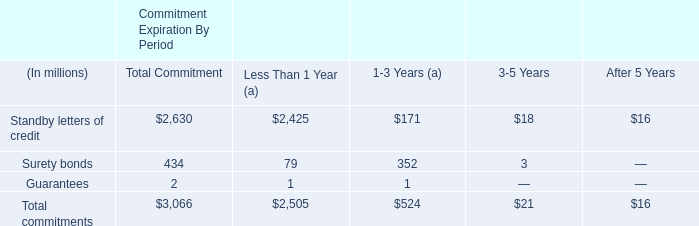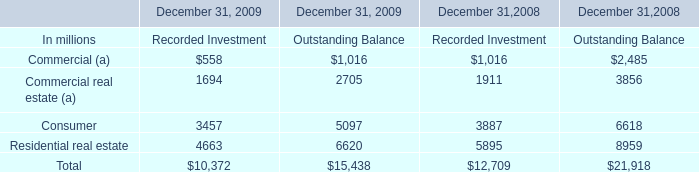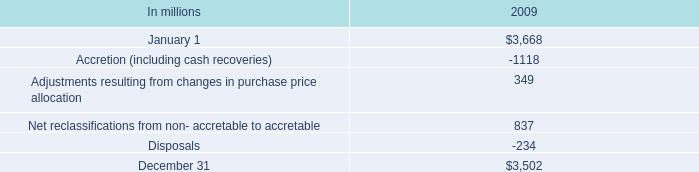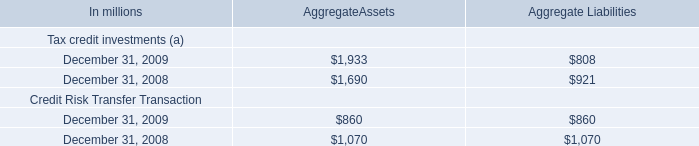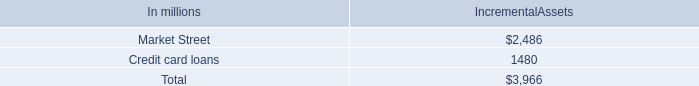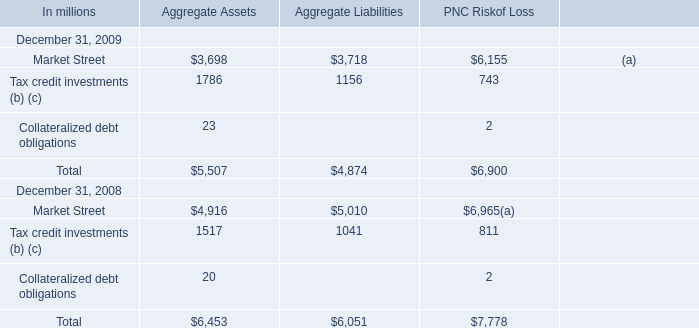What's the current growth rate of Collateralized debt obligations for aggregate assets? (in %) 
Computations: ((23 - 20) / 20)
Answer: 0.15. 